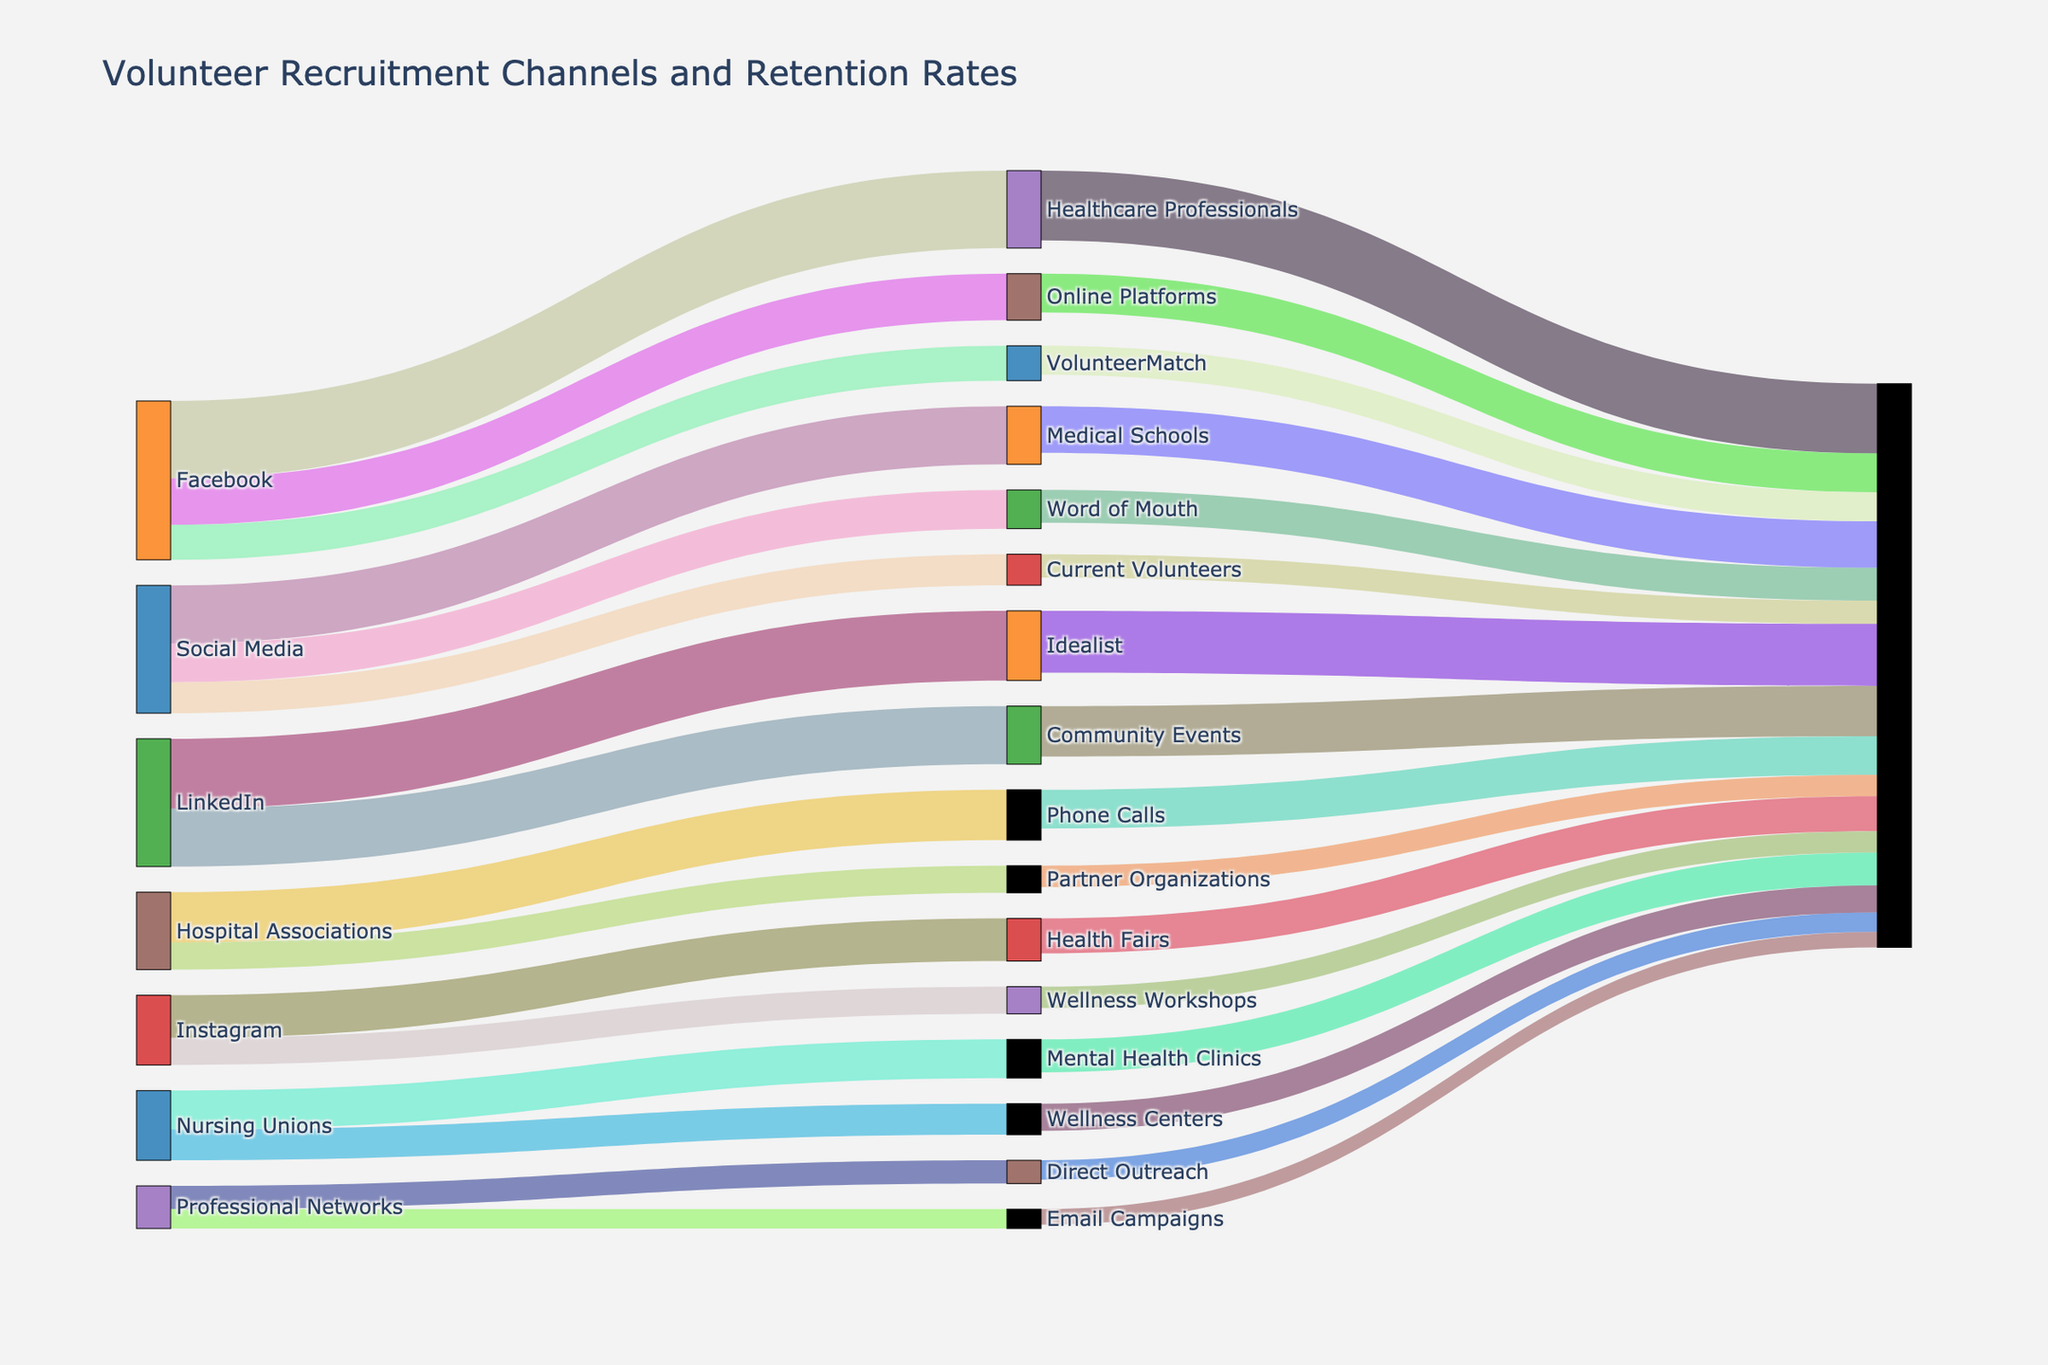What's the title of the figure? The title of the figure is often prominently displayed at the top, summarizing the main topic of the visualization. In this case, the title is "Volunteer Recruitment Channels and Retention Rates".
Answer: Volunteer Recruitment Channels and Retention Rates How many recruitment sources are represented in the figure? To determine the number of recruitment sources, count the initial (leftmost) nodes connecting to the next level. Each unique named source like "Social Media" or "Professional Networks" represents a distinct recruitment source.
Answer: 6 Which recruitment channel has the highest number of volunteers? Examine each channel listed under different sources and compare their volunteer counts. Hospital Associations under Professional Networks has the highest number.
Answer: Hospital Associations What is the total number of volunteers recruited through Social Media? Sum the volunteers from all channels under the Social Media source: Facebook (150), LinkedIn (100), and Instagram (80). Calculation: 150 + 100 + 80.
Answer: 330 Between Facebook and Instagram, which channel retains a higher percentage of its volunteers? Calculate retention percentage for both channels: 
- Facebook: 120 retained out of 150, which is (120/150) * 100 = 80%
- Instagram: 60 retained out of 80, which is (60/80) * 100 = 75%
Compare the percentages.
Answer: Facebook How many volunteers are retained from Word of Mouth sources in total? Sum the retained volunteers from both channels under Word of Mouth: 
- Current Volunteers retain 160
- Healthcare Professionals retain 130
Calculation: 160 + 130
Answer: 290 Which recruitment source has the lowest retention in terms of total numbers? Total retained volunteers for each source need to be summed:
- Social Media: 120 + 85 + 60 = 265
- Professional Networks: 180 + 100 + 75 = 355
- Word of Mouth: 160 + 130 = 290
- Online Platforms: 90 + 55 = 145
- Community Events: 50 + 40 = 90
- Direct Outreach: 100 + 55 = 155
- Partner Organizations: 85 + 70 = 155
The lowest sum indicates the source with the lowest retention.
Answer: Community Events What is the retention rate for volunteers recruited through VolunteerMatch? Calculate retention percentage by dividing the number of retained volunteers by the total recruited and multiplying by 100: (90/110) * 100.
Answer: 81.82% Compare the retention rates between Hospital Associations and VolunteerMatch. Which is higher? Calculate both retention rates:
- Hospital Associations: (180/200) * 100 = 90%
- VolunteerMatch: (90/110) * 100 = 81.82%
Compare the percentages to see which is higher.
Answer: Hospital Associations Among the recruitment channels listed, which one has the lowest absolute number of retained volunteers? Identify the lowest number in the retention column. Wellness Workshops under Community Events has the lowest retention.
Answer: Wellness Workshops 